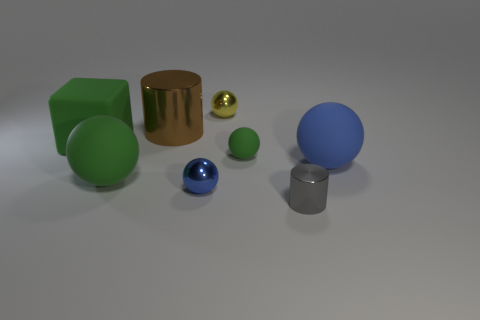Subtract all blue spheres. How many spheres are left? 3 Subtract all yellow balls. How many balls are left? 4 Subtract all balls. How many objects are left? 3 Subtract 3 balls. How many balls are left? 2 Add 1 blue balls. How many objects exist? 9 Add 6 green things. How many green things exist? 9 Subtract 0 cyan cubes. How many objects are left? 8 Subtract all cyan cylinders. Subtract all brown spheres. How many cylinders are left? 2 Subtract all purple cylinders. How many yellow spheres are left? 1 Subtract all cylinders. Subtract all tiny green spheres. How many objects are left? 5 